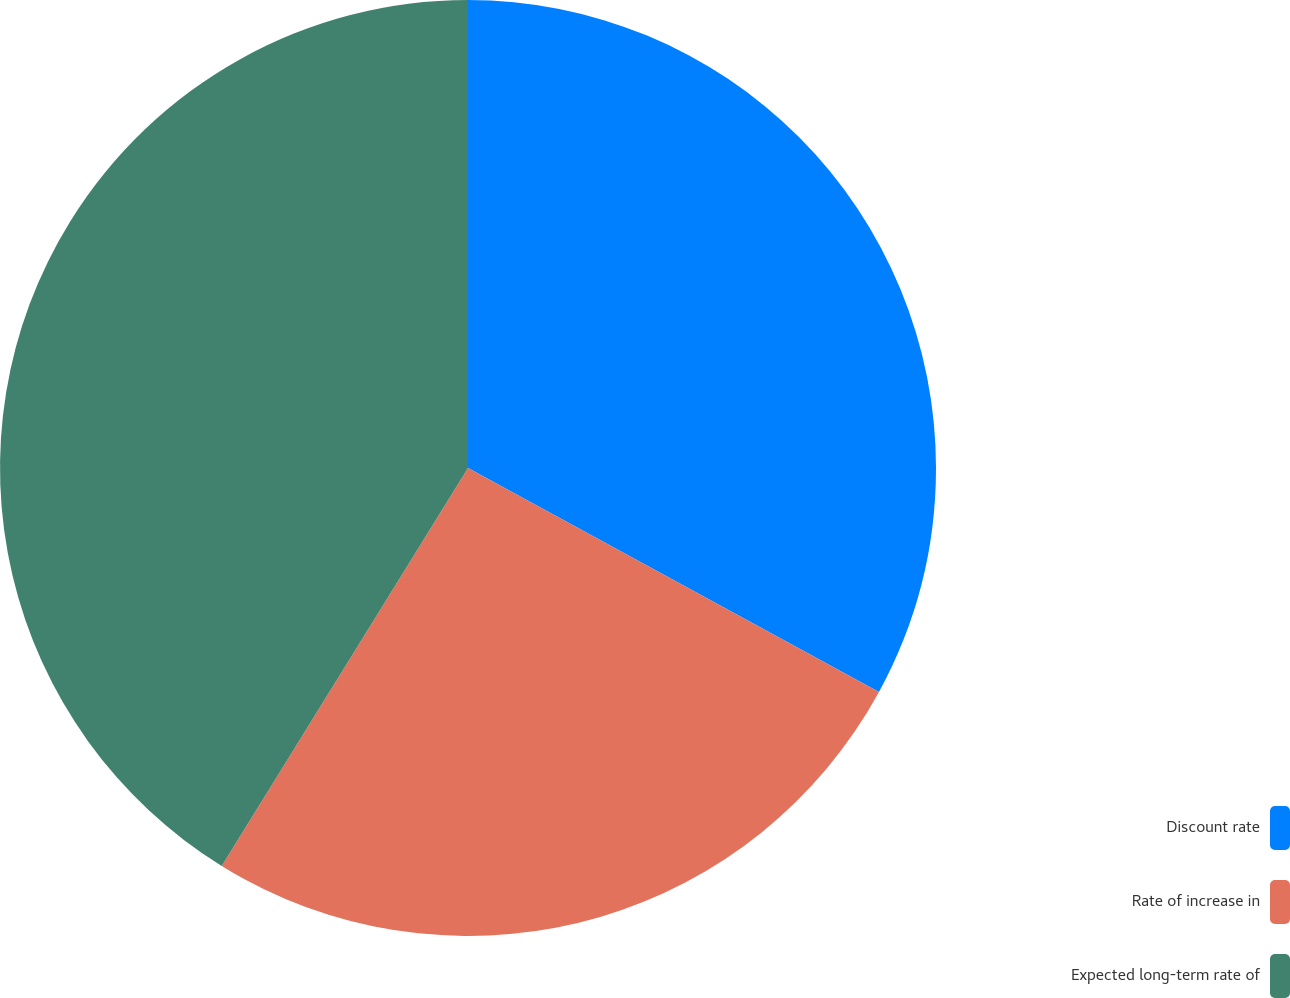Convert chart to OTSL. <chart><loc_0><loc_0><loc_500><loc_500><pie_chart><fcel>Discount rate<fcel>Rate of increase in<fcel>Expected long-term rate of<nl><fcel>32.94%<fcel>25.88%<fcel>41.18%<nl></chart> 